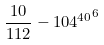Convert formula to latex. <formula><loc_0><loc_0><loc_500><loc_500>\frac { 1 0 } { 1 1 2 } - { 1 0 4 ^ { 4 0 } } ^ { 6 }</formula> 